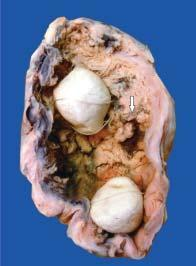does the lumen of the gallbladder contain irregular, friable papillary growth arising from mucosa arrow?
Answer the question using a single word or phrase. Yes 